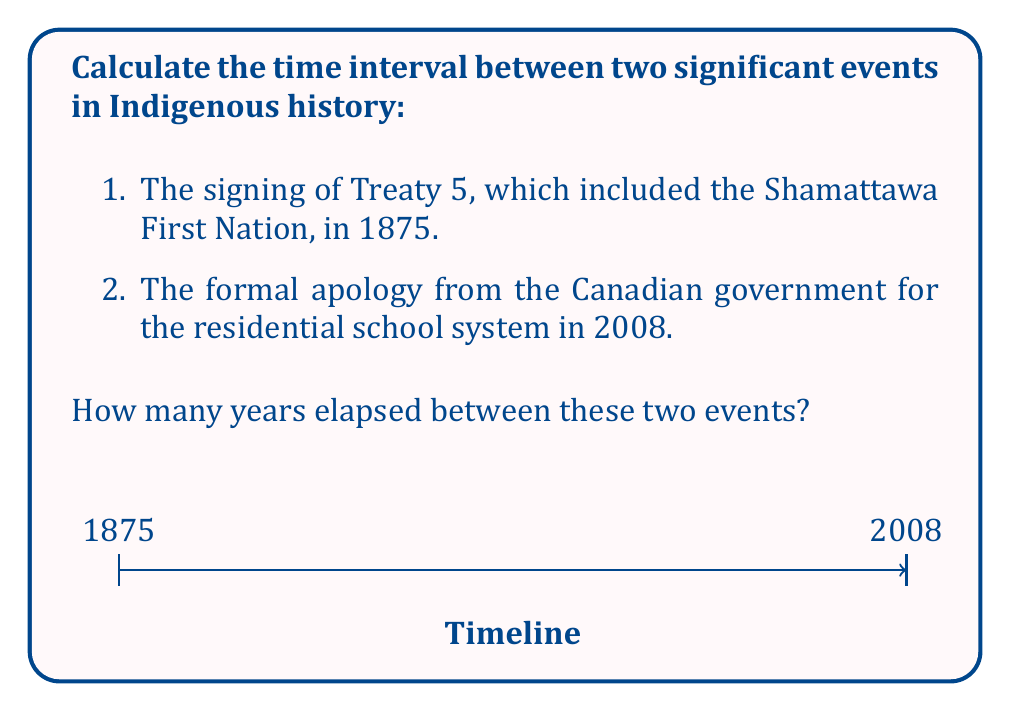Can you answer this question? To calculate the time interval between these two events, we need to subtract the earlier year from the later year:

1. Identify the years:
   - Treaty 5 signing: 1875
   - Canadian government apology: 2008

2. Set up the subtraction:
   $$ 2008 - 1875 $$

3. Perform the subtraction:
   $$ 2008 - 1875 = 133 $$

Therefore, 133 years elapsed between the signing of Treaty 5 and the Canadian government's formal apology for the residential school system.
Answer: 133 years 